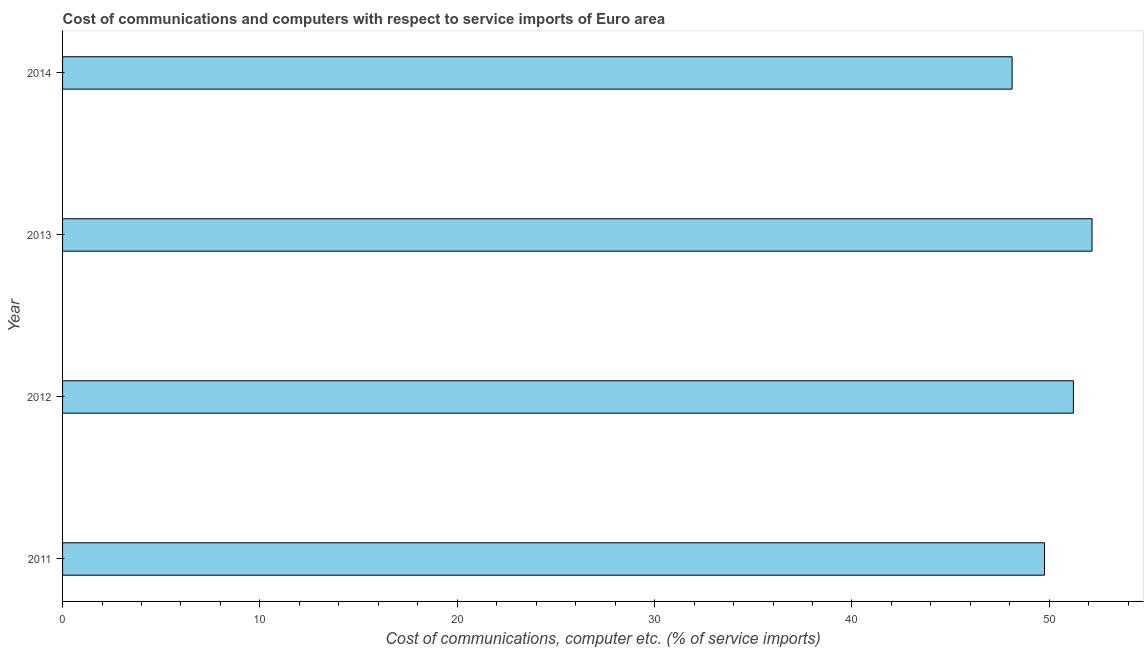Does the graph contain any zero values?
Provide a short and direct response. No. Does the graph contain grids?
Your answer should be compact. No. What is the title of the graph?
Keep it short and to the point. Cost of communications and computers with respect to service imports of Euro area. What is the label or title of the X-axis?
Your answer should be compact. Cost of communications, computer etc. (% of service imports). What is the cost of communications and computer in 2012?
Provide a short and direct response. 51.22. Across all years, what is the maximum cost of communications and computer?
Provide a succinct answer. 52.17. Across all years, what is the minimum cost of communications and computer?
Make the answer very short. 48.12. In which year was the cost of communications and computer maximum?
Provide a short and direct response. 2013. What is the sum of the cost of communications and computer?
Offer a very short reply. 201.26. What is the difference between the cost of communications and computer in 2012 and 2013?
Provide a succinct answer. -0.94. What is the average cost of communications and computer per year?
Your answer should be very brief. 50.31. What is the median cost of communications and computer?
Give a very brief answer. 50.49. In how many years, is the cost of communications and computer greater than 20 %?
Keep it short and to the point. 4. What is the ratio of the cost of communications and computer in 2012 to that in 2013?
Your answer should be very brief. 0.98. What is the difference between the highest and the second highest cost of communications and computer?
Your response must be concise. 0.94. What is the difference between the highest and the lowest cost of communications and computer?
Keep it short and to the point. 4.05. In how many years, is the cost of communications and computer greater than the average cost of communications and computer taken over all years?
Your answer should be very brief. 2. How many bars are there?
Offer a terse response. 4. How many years are there in the graph?
Ensure brevity in your answer.  4. What is the difference between two consecutive major ticks on the X-axis?
Give a very brief answer. 10. Are the values on the major ticks of X-axis written in scientific E-notation?
Make the answer very short. No. What is the Cost of communications, computer etc. (% of service imports) of 2011?
Provide a short and direct response. 49.76. What is the Cost of communications, computer etc. (% of service imports) of 2012?
Ensure brevity in your answer.  51.22. What is the Cost of communications, computer etc. (% of service imports) in 2013?
Your response must be concise. 52.17. What is the Cost of communications, computer etc. (% of service imports) of 2014?
Ensure brevity in your answer.  48.12. What is the difference between the Cost of communications, computer etc. (% of service imports) in 2011 and 2012?
Offer a terse response. -1.47. What is the difference between the Cost of communications, computer etc. (% of service imports) in 2011 and 2013?
Offer a terse response. -2.41. What is the difference between the Cost of communications, computer etc. (% of service imports) in 2011 and 2014?
Ensure brevity in your answer.  1.64. What is the difference between the Cost of communications, computer etc. (% of service imports) in 2012 and 2013?
Give a very brief answer. -0.94. What is the difference between the Cost of communications, computer etc. (% of service imports) in 2012 and 2014?
Your answer should be compact. 3.11. What is the difference between the Cost of communications, computer etc. (% of service imports) in 2013 and 2014?
Your answer should be compact. 4.05. What is the ratio of the Cost of communications, computer etc. (% of service imports) in 2011 to that in 2012?
Provide a succinct answer. 0.97. What is the ratio of the Cost of communications, computer etc. (% of service imports) in 2011 to that in 2013?
Offer a very short reply. 0.95. What is the ratio of the Cost of communications, computer etc. (% of service imports) in 2011 to that in 2014?
Offer a very short reply. 1.03. What is the ratio of the Cost of communications, computer etc. (% of service imports) in 2012 to that in 2014?
Ensure brevity in your answer.  1.06. What is the ratio of the Cost of communications, computer etc. (% of service imports) in 2013 to that in 2014?
Make the answer very short. 1.08. 